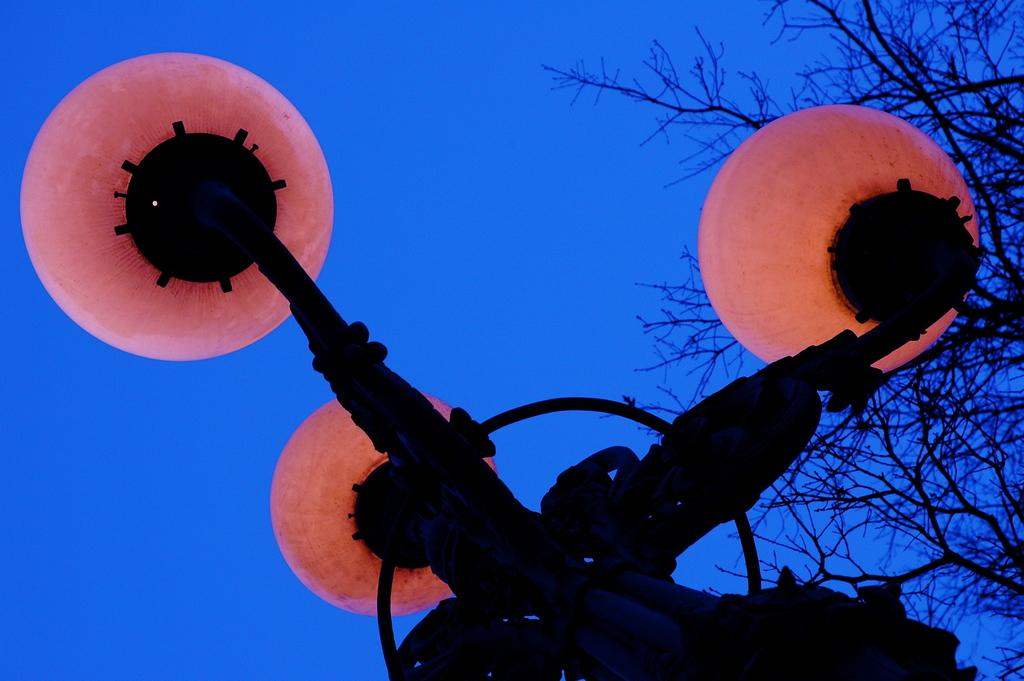What is on the pole in the image? There are lights on a pole in the image. What can be seen in the background of the image? There is a tree visible in the background of the image, and the sky is blue. What type of drug is being sold by the father at the base of the tree in the image? There is no father, drug, or base of a tree present in the image. 